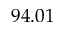Convert formula to latex. <formula><loc_0><loc_0><loc_500><loc_500>9 4 . 0 1</formula> 